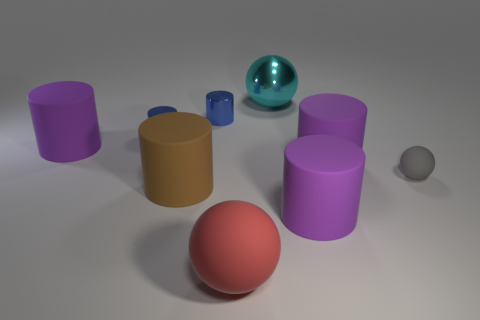What number of other metal objects have the same shape as the big cyan shiny thing?
Your response must be concise. 0. Is the material of the big cyan ball the same as the big purple cylinder to the left of the large matte ball?
Provide a succinct answer. No. There is a cyan object that is the same size as the red thing; what material is it?
Your answer should be very brief. Metal. Is there a rubber thing of the same size as the cyan metal ball?
Make the answer very short. Yes. There is a red thing that is the same size as the cyan ball; what shape is it?
Offer a very short reply. Sphere. What number of other objects are there of the same color as the big shiny sphere?
Ensure brevity in your answer.  0. There is a big object that is both left of the big cyan shiny object and to the right of the big brown rubber cylinder; what shape is it?
Provide a succinct answer. Sphere. Is there a small sphere in front of the sphere that is behind the big purple rubber cylinder to the left of the red rubber sphere?
Give a very brief answer. Yes. How many other objects are there of the same material as the small gray ball?
Ensure brevity in your answer.  5. How many cyan balls are there?
Offer a terse response. 1. 